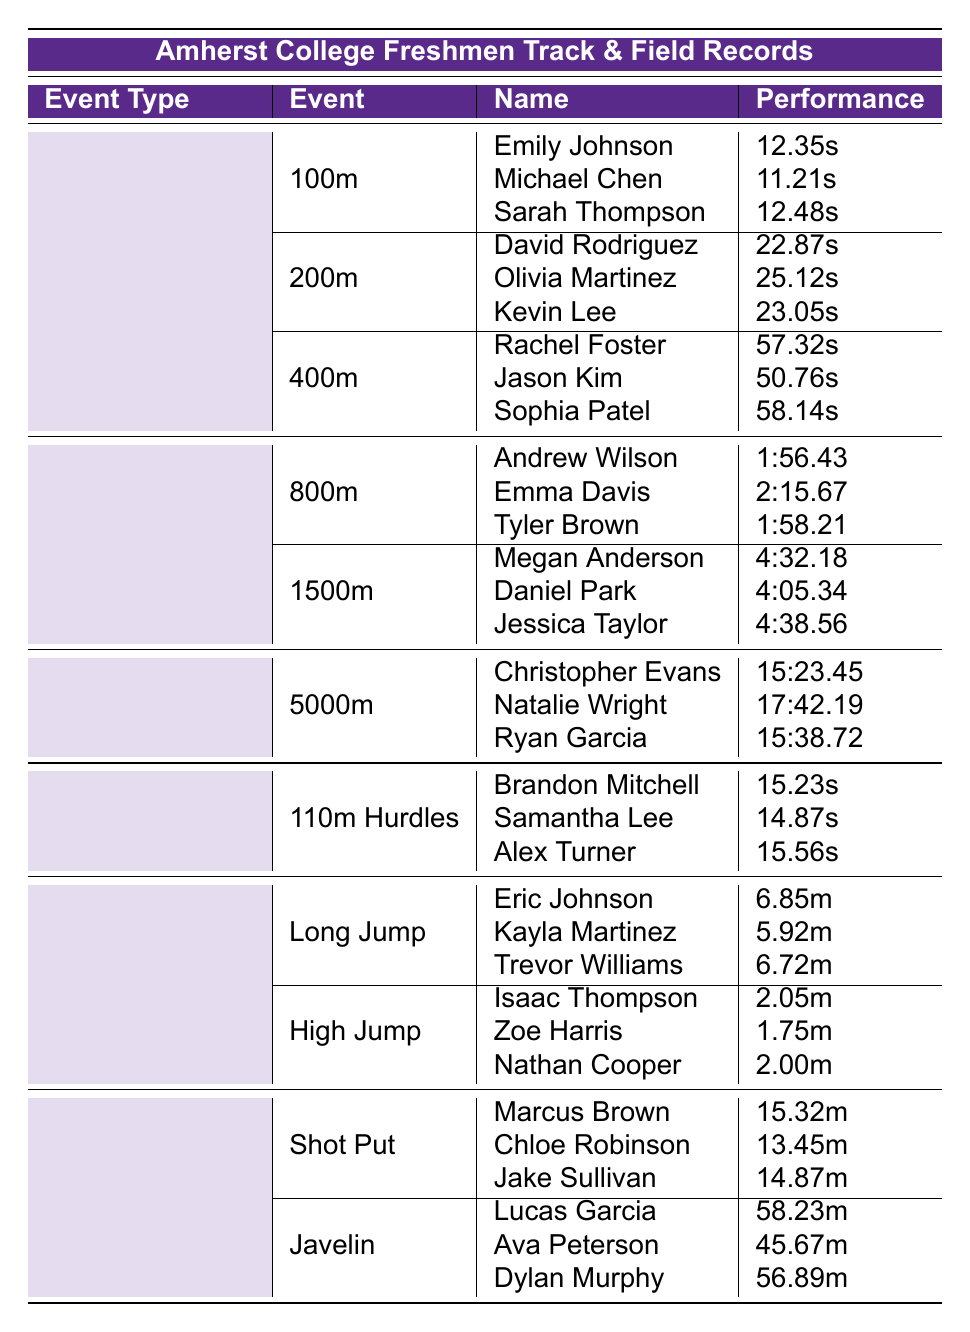What is the fastest time recorded for the 100m dash? From the table, the 100m event has three athletes with times listed. Michael Chen has the fastest time at 11.21 seconds.
Answer: 11.21 seconds Who achieved the longest jump in the Long Jump event? Referring to the Long Jump section, Eric Johnson has the longest distance recorded at 6.85 meters.
Answer: 6.85 meters Which athlete has the best record in the 400m event? In the 400m section, the times are listed for Rachel Foster, Jason Kim, and Sophia Patel. Jason Kim has the best time at 50.76 seconds.
Answer: 50.76 seconds Is Samuel Lee competing in the hurdles event? The table lists athletes for the 110m Hurdles but does not include anyone named Samuel Lee, so the answer is no.
Answer: No What is the combined distance of the top two shot put performances? In the Shot Put section, the distances are Marcus Brown at 15.32m and Chloe Robinson at 13.45m. Summing these gives 15.32 + 13.45 = 28.77 meters.
Answer: 28.77 meters What is the average time of the 800m runners? The times for the 800m are Andrew Wilson (1:56.43), Emma Davis (2:15.67), and Tyler Brown (1:58.21). To calculate the average, first convert the times to seconds: (116.43 + 135.67 + 118.21) = 370.31 seconds, then divide by 3, resulting in an average of 123.44 seconds or 2:03.44.
Answer: 2:03.44 Which event had the slowest time recorded? Comparing the fastest times from each event, the 5000m results list Christopher Evans at 15:23.45. All other events have faster times, confirming that 15:23.45 is the slowest.
Answer: 15:23.45 Is there an athlete named Ava Peterson in the Javelin event? Checking the Javelin section of the table, Ava Peterson is listed, confirming that yes, she is competing.
Answer: Yes What is the difference in performance between the fastest 200m and the fastest 400m runners? The fastest 200m is David Rodriguez at 22.87 seconds and the fastest 400m is Jason Kim at 50.76 seconds. The difference is 50.76 - 22.87 = 27.89 seconds.
Answer: 27.89 seconds Who holds the best time in the 1500m event? By reviewing the 1500m entries, Daniel Park has the fastest time at 4:05.34, thus he holds the best time in this event.
Answer: 4:05.34 